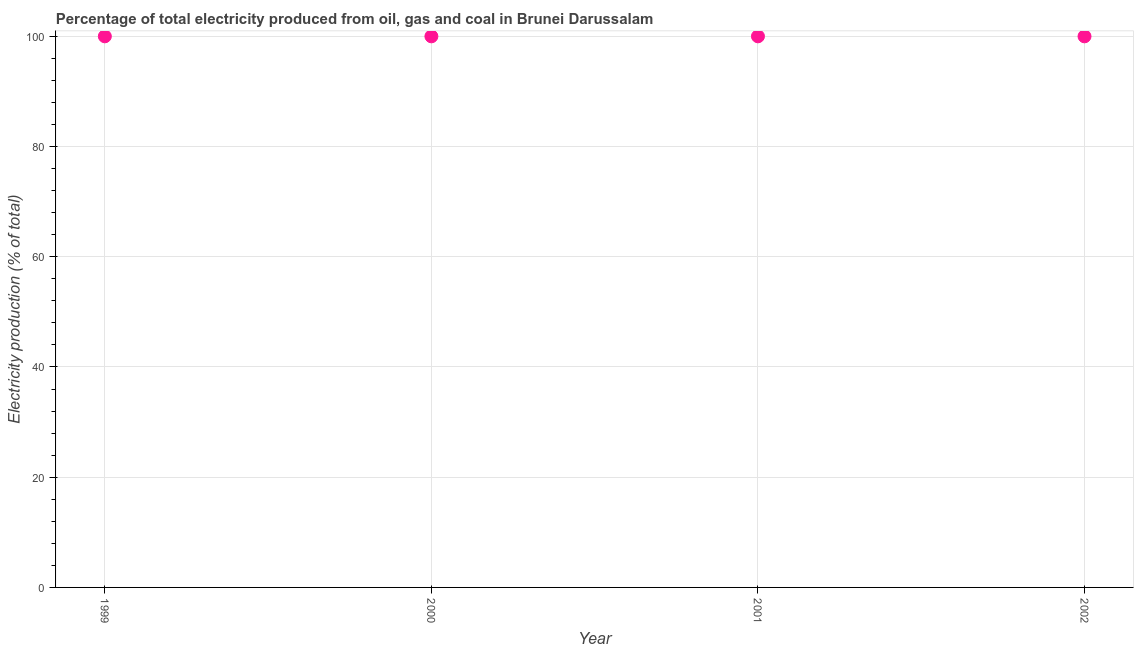In which year was the electricity production maximum?
Offer a terse response. 1999. What is the sum of the electricity production?
Provide a short and direct response. 400. Is the electricity production in 1999 less than that in 2002?
Your response must be concise. No. Is the difference between the electricity production in 2000 and 2001 greater than the difference between any two years?
Ensure brevity in your answer.  Yes. What is the difference between the highest and the second highest electricity production?
Your response must be concise. 0. How many years are there in the graph?
Your response must be concise. 4. Does the graph contain grids?
Give a very brief answer. Yes. What is the title of the graph?
Provide a succinct answer. Percentage of total electricity produced from oil, gas and coal in Brunei Darussalam. What is the label or title of the X-axis?
Offer a terse response. Year. What is the label or title of the Y-axis?
Your answer should be compact. Electricity production (% of total). What is the difference between the Electricity production (% of total) in 1999 and 2000?
Ensure brevity in your answer.  0. What is the difference between the Electricity production (% of total) in 1999 and 2002?
Give a very brief answer. 0. What is the difference between the Electricity production (% of total) in 2000 and 2001?
Your answer should be very brief. 0. What is the ratio of the Electricity production (% of total) in 1999 to that in 2001?
Keep it short and to the point. 1. What is the ratio of the Electricity production (% of total) in 1999 to that in 2002?
Your answer should be very brief. 1. What is the ratio of the Electricity production (% of total) in 2000 to that in 2001?
Offer a terse response. 1. What is the ratio of the Electricity production (% of total) in 2001 to that in 2002?
Offer a very short reply. 1. 